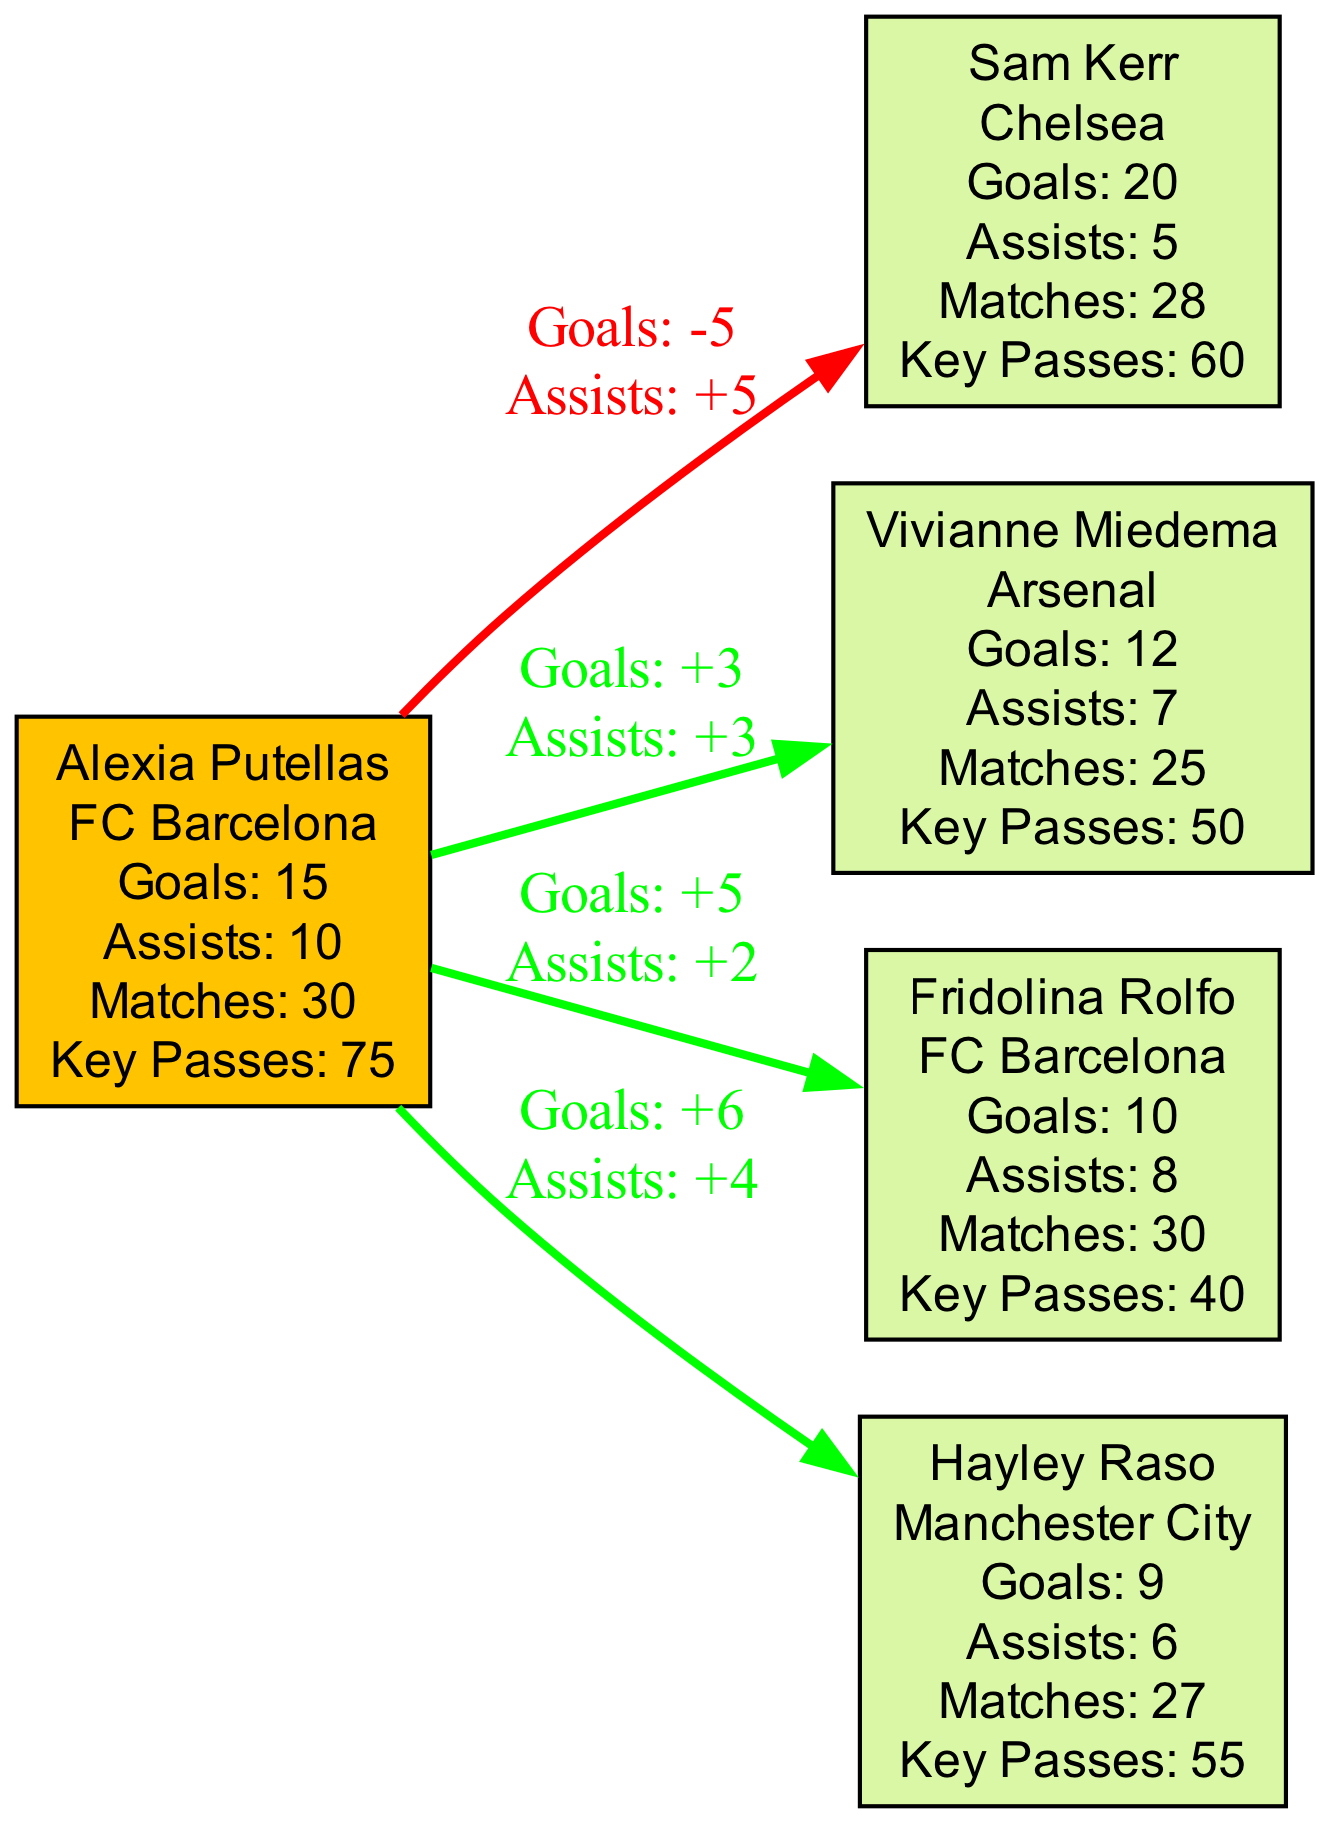What is Alexia Putellas' total goal count for the 2022-2023 season? The diagram indicates that Alexia Putellas scored a total of 15 goals, as stated in her node information.
Answer: 15 How many assists did Fridolina Rolfo have? Based on the node information for Fridolina Rolfo, she had a total of 8 assists this season.
Answer: 8 Who scored more goals, Alexia Putellas or Hayley Raso? The comparison shows that Alexia Putellas scored 15 goals while Hayley Raso scored 9 goals. Therefore, Alexia Putellas scored more goals than Hayley Raso.
Answer: Alexia Putellas What is the goal difference between Alexia Putellas and Vivianne Miedema? The diagram shows that the goal difference is +3, indicating that Alexia Putellas scored 3 more goals than Vivianne Miedema.
Answer: 3 How many key passes did Sam Kerr make this season? Sam Kerr's node shows that she made a total of 60 key passes in the season.
Answer: 60 How many total players are represented in the diagram? There are five players represented in the diagram: Alexia Putellas, Sam Kerr, Vivianne Miedema, Fridolina Rolfo, and Hayley Raso.
Answer: 5 What can be inferred about Alexia Putellas' assists compared to Fridolina Rolfo's? The goal difference indicates that Alexia Putellas had 2 more assists than Fridolina Rolfo (10 vs 8), showing she is more effective in terms of assists compared to Rolfo.
Answer: 2 more assists Did Alexia Putellas have a higher assist total than all other players shown? Yes, considering the assists tallied on the diagram, Alexia Putellas scored 10 assists, which is the highest amount compared to all other players listed.
Answer: Yes Which player had the least number of goals? Looking at the nodes, Hayley Raso has the least number of goals with a total of 9.
Answer: Hayley Raso 